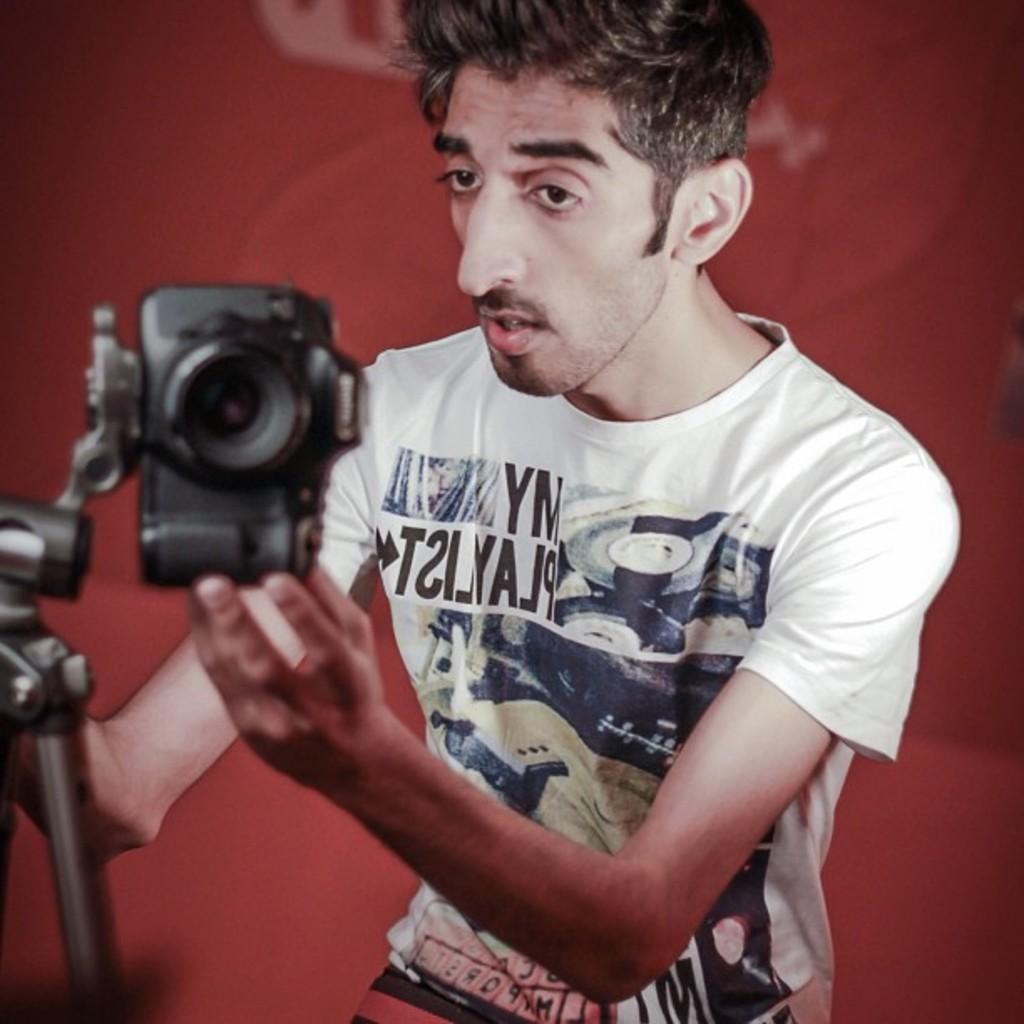What is the man in the image doing? The man is holding a camera in one hand and a stand in the other hand. What is the man wearing in the image? The man is wearing a white T-shirt. What type of oatmeal is the man eating in the image? There is no oatmeal present in the image. Is the man in the image playing a game with the camera and stand? The image does not show the man playing a game; he is holding a camera and a stand, but there is no indication of a game being played. 